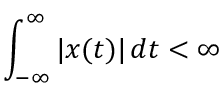<formula> <loc_0><loc_0><loc_500><loc_500>\int _ { - \infty } ^ { \infty } | x ( t ) | \, d t < \infty</formula> 